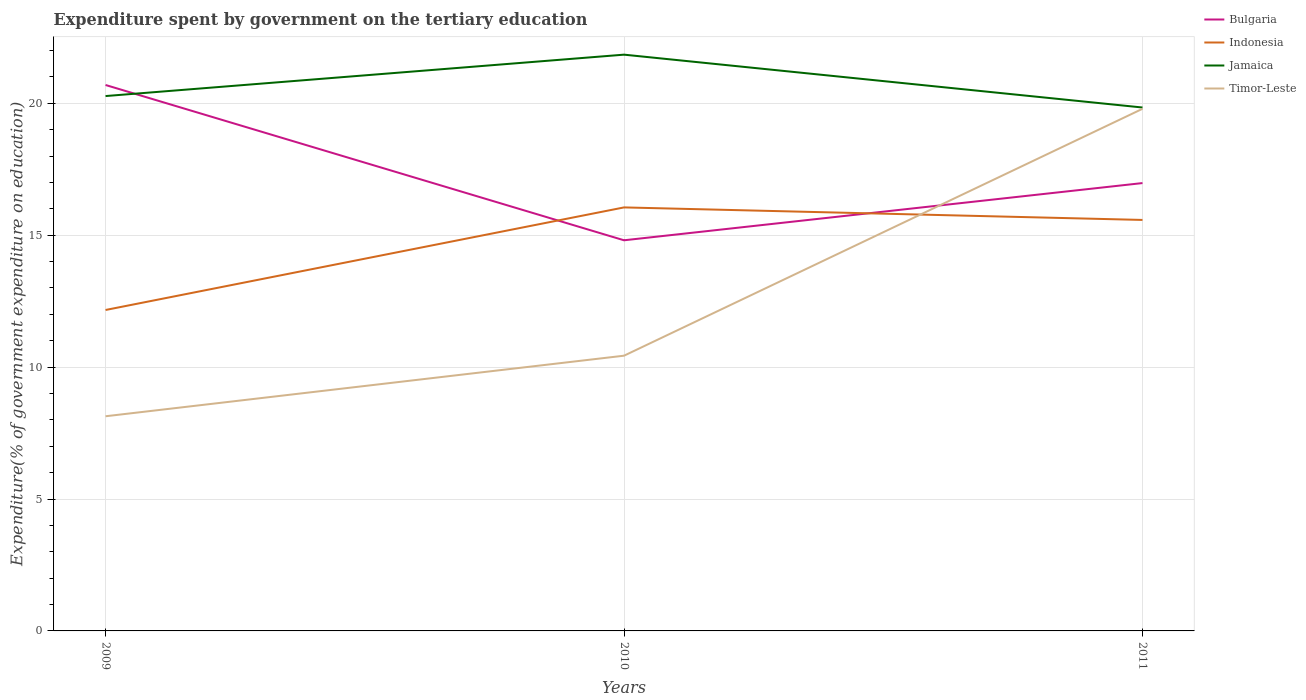How many different coloured lines are there?
Offer a very short reply. 4. Is the number of lines equal to the number of legend labels?
Give a very brief answer. Yes. Across all years, what is the maximum expenditure spent by government on the tertiary education in Bulgaria?
Your response must be concise. 14.81. What is the total expenditure spent by government on the tertiary education in Jamaica in the graph?
Provide a succinct answer. -1.57. What is the difference between the highest and the second highest expenditure spent by government on the tertiary education in Timor-Leste?
Make the answer very short. 11.65. What is the difference between the highest and the lowest expenditure spent by government on the tertiary education in Timor-Leste?
Make the answer very short. 1. Is the expenditure spent by government on the tertiary education in Indonesia strictly greater than the expenditure spent by government on the tertiary education in Jamaica over the years?
Offer a very short reply. Yes. How many lines are there?
Ensure brevity in your answer.  4. What is the difference between two consecutive major ticks on the Y-axis?
Offer a very short reply. 5. Are the values on the major ticks of Y-axis written in scientific E-notation?
Ensure brevity in your answer.  No. Does the graph contain any zero values?
Provide a succinct answer. No. Does the graph contain grids?
Your answer should be very brief. Yes. What is the title of the graph?
Ensure brevity in your answer.  Expenditure spent by government on the tertiary education. Does "Kyrgyz Republic" appear as one of the legend labels in the graph?
Your answer should be compact. No. What is the label or title of the X-axis?
Provide a short and direct response. Years. What is the label or title of the Y-axis?
Provide a short and direct response. Expenditure(% of government expenditure on education). What is the Expenditure(% of government expenditure on education) in Bulgaria in 2009?
Provide a succinct answer. 20.69. What is the Expenditure(% of government expenditure on education) of Indonesia in 2009?
Keep it short and to the point. 12.17. What is the Expenditure(% of government expenditure on education) of Jamaica in 2009?
Make the answer very short. 20.27. What is the Expenditure(% of government expenditure on education) of Timor-Leste in 2009?
Provide a short and direct response. 8.14. What is the Expenditure(% of government expenditure on education) of Bulgaria in 2010?
Offer a terse response. 14.81. What is the Expenditure(% of government expenditure on education) in Indonesia in 2010?
Provide a succinct answer. 16.05. What is the Expenditure(% of government expenditure on education) in Jamaica in 2010?
Offer a very short reply. 21.84. What is the Expenditure(% of government expenditure on education) in Timor-Leste in 2010?
Offer a terse response. 10.43. What is the Expenditure(% of government expenditure on education) of Bulgaria in 2011?
Your answer should be very brief. 16.98. What is the Expenditure(% of government expenditure on education) of Indonesia in 2011?
Provide a short and direct response. 15.58. What is the Expenditure(% of government expenditure on education) of Jamaica in 2011?
Your response must be concise. 19.84. What is the Expenditure(% of government expenditure on education) of Timor-Leste in 2011?
Give a very brief answer. 19.79. Across all years, what is the maximum Expenditure(% of government expenditure on education) of Bulgaria?
Ensure brevity in your answer.  20.69. Across all years, what is the maximum Expenditure(% of government expenditure on education) of Indonesia?
Ensure brevity in your answer.  16.05. Across all years, what is the maximum Expenditure(% of government expenditure on education) of Jamaica?
Ensure brevity in your answer.  21.84. Across all years, what is the maximum Expenditure(% of government expenditure on education) of Timor-Leste?
Provide a succinct answer. 19.79. Across all years, what is the minimum Expenditure(% of government expenditure on education) of Bulgaria?
Give a very brief answer. 14.81. Across all years, what is the minimum Expenditure(% of government expenditure on education) in Indonesia?
Make the answer very short. 12.17. Across all years, what is the minimum Expenditure(% of government expenditure on education) in Jamaica?
Your answer should be compact. 19.84. Across all years, what is the minimum Expenditure(% of government expenditure on education) in Timor-Leste?
Give a very brief answer. 8.14. What is the total Expenditure(% of government expenditure on education) of Bulgaria in the graph?
Provide a short and direct response. 52.48. What is the total Expenditure(% of government expenditure on education) in Indonesia in the graph?
Provide a short and direct response. 43.8. What is the total Expenditure(% of government expenditure on education) in Jamaica in the graph?
Your answer should be compact. 61.96. What is the total Expenditure(% of government expenditure on education) of Timor-Leste in the graph?
Your response must be concise. 38.36. What is the difference between the Expenditure(% of government expenditure on education) in Bulgaria in 2009 and that in 2010?
Provide a succinct answer. 5.89. What is the difference between the Expenditure(% of government expenditure on education) in Indonesia in 2009 and that in 2010?
Your response must be concise. -3.89. What is the difference between the Expenditure(% of government expenditure on education) of Jamaica in 2009 and that in 2010?
Your answer should be very brief. -1.57. What is the difference between the Expenditure(% of government expenditure on education) of Timor-Leste in 2009 and that in 2010?
Give a very brief answer. -2.3. What is the difference between the Expenditure(% of government expenditure on education) in Bulgaria in 2009 and that in 2011?
Keep it short and to the point. 3.72. What is the difference between the Expenditure(% of government expenditure on education) in Indonesia in 2009 and that in 2011?
Offer a terse response. -3.41. What is the difference between the Expenditure(% of government expenditure on education) in Jamaica in 2009 and that in 2011?
Give a very brief answer. 0.43. What is the difference between the Expenditure(% of government expenditure on education) of Timor-Leste in 2009 and that in 2011?
Ensure brevity in your answer.  -11.65. What is the difference between the Expenditure(% of government expenditure on education) in Bulgaria in 2010 and that in 2011?
Offer a terse response. -2.17. What is the difference between the Expenditure(% of government expenditure on education) in Indonesia in 2010 and that in 2011?
Make the answer very short. 0.47. What is the difference between the Expenditure(% of government expenditure on education) of Jamaica in 2010 and that in 2011?
Your answer should be compact. 2. What is the difference between the Expenditure(% of government expenditure on education) of Timor-Leste in 2010 and that in 2011?
Make the answer very short. -9.36. What is the difference between the Expenditure(% of government expenditure on education) of Bulgaria in 2009 and the Expenditure(% of government expenditure on education) of Indonesia in 2010?
Keep it short and to the point. 4.64. What is the difference between the Expenditure(% of government expenditure on education) in Bulgaria in 2009 and the Expenditure(% of government expenditure on education) in Jamaica in 2010?
Your answer should be compact. -1.15. What is the difference between the Expenditure(% of government expenditure on education) of Bulgaria in 2009 and the Expenditure(% of government expenditure on education) of Timor-Leste in 2010?
Give a very brief answer. 10.26. What is the difference between the Expenditure(% of government expenditure on education) in Indonesia in 2009 and the Expenditure(% of government expenditure on education) in Jamaica in 2010?
Offer a very short reply. -9.68. What is the difference between the Expenditure(% of government expenditure on education) in Indonesia in 2009 and the Expenditure(% of government expenditure on education) in Timor-Leste in 2010?
Ensure brevity in your answer.  1.73. What is the difference between the Expenditure(% of government expenditure on education) in Jamaica in 2009 and the Expenditure(% of government expenditure on education) in Timor-Leste in 2010?
Provide a succinct answer. 9.84. What is the difference between the Expenditure(% of government expenditure on education) of Bulgaria in 2009 and the Expenditure(% of government expenditure on education) of Indonesia in 2011?
Offer a terse response. 5.12. What is the difference between the Expenditure(% of government expenditure on education) in Bulgaria in 2009 and the Expenditure(% of government expenditure on education) in Jamaica in 2011?
Give a very brief answer. 0.85. What is the difference between the Expenditure(% of government expenditure on education) of Bulgaria in 2009 and the Expenditure(% of government expenditure on education) of Timor-Leste in 2011?
Ensure brevity in your answer.  0.9. What is the difference between the Expenditure(% of government expenditure on education) in Indonesia in 2009 and the Expenditure(% of government expenditure on education) in Jamaica in 2011?
Your answer should be compact. -7.67. What is the difference between the Expenditure(% of government expenditure on education) in Indonesia in 2009 and the Expenditure(% of government expenditure on education) in Timor-Leste in 2011?
Offer a very short reply. -7.63. What is the difference between the Expenditure(% of government expenditure on education) of Jamaica in 2009 and the Expenditure(% of government expenditure on education) of Timor-Leste in 2011?
Give a very brief answer. 0.48. What is the difference between the Expenditure(% of government expenditure on education) in Bulgaria in 2010 and the Expenditure(% of government expenditure on education) in Indonesia in 2011?
Make the answer very short. -0.77. What is the difference between the Expenditure(% of government expenditure on education) in Bulgaria in 2010 and the Expenditure(% of government expenditure on education) in Jamaica in 2011?
Provide a short and direct response. -5.03. What is the difference between the Expenditure(% of government expenditure on education) in Bulgaria in 2010 and the Expenditure(% of government expenditure on education) in Timor-Leste in 2011?
Offer a terse response. -4.98. What is the difference between the Expenditure(% of government expenditure on education) of Indonesia in 2010 and the Expenditure(% of government expenditure on education) of Jamaica in 2011?
Offer a terse response. -3.79. What is the difference between the Expenditure(% of government expenditure on education) in Indonesia in 2010 and the Expenditure(% of government expenditure on education) in Timor-Leste in 2011?
Make the answer very short. -3.74. What is the difference between the Expenditure(% of government expenditure on education) in Jamaica in 2010 and the Expenditure(% of government expenditure on education) in Timor-Leste in 2011?
Your answer should be compact. 2.05. What is the average Expenditure(% of government expenditure on education) in Bulgaria per year?
Give a very brief answer. 17.49. What is the average Expenditure(% of government expenditure on education) of Indonesia per year?
Provide a short and direct response. 14.6. What is the average Expenditure(% of government expenditure on education) in Jamaica per year?
Your answer should be very brief. 20.65. What is the average Expenditure(% of government expenditure on education) of Timor-Leste per year?
Provide a short and direct response. 12.79. In the year 2009, what is the difference between the Expenditure(% of government expenditure on education) in Bulgaria and Expenditure(% of government expenditure on education) in Indonesia?
Provide a succinct answer. 8.53. In the year 2009, what is the difference between the Expenditure(% of government expenditure on education) of Bulgaria and Expenditure(% of government expenditure on education) of Jamaica?
Your answer should be compact. 0.42. In the year 2009, what is the difference between the Expenditure(% of government expenditure on education) of Bulgaria and Expenditure(% of government expenditure on education) of Timor-Leste?
Offer a terse response. 12.56. In the year 2009, what is the difference between the Expenditure(% of government expenditure on education) in Indonesia and Expenditure(% of government expenditure on education) in Jamaica?
Your answer should be very brief. -8.11. In the year 2009, what is the difference between the Expenditure(% of government expenditure on education) in Indonesia and Expenditure(% of government expenditure on education) in Timor-Leste?
Provide a succinct answer. 4.03. In the year 2009, what is the difference between the Expenditure(% of government expenditure on education) of Jamaica and Expenditure(% of government expenditure on education) of Timor-Leste?
Your answer should be compact. 12.14. In the year 2010, what is the difference between the Expenditure(% of government expenditure on education) of Bulgaria and Expenditure(% of government expenditure on education) of Indonesia?
Offer a very short reply. -1.25. In the year 2010, what is the difference between the Expenditure(% of government expenditure on education) in Bulgaria and Expenditure(% of government expenditure on education) in Jamaica?
Provide a short and direct response. -7.04. In the year 2010, what is the difference between the Expenditure(% of government expenditure on education) in Bulgaria and Expenditure(% of government expenditure on education) in Timor-Leste?
Provide a short and direct response. 4.37. In the year 2010, what is the difference between the Expenditure(% of government expenditure on education) in Indonesia and Expenditure(% of government expenditure on education) in Jamaica?
Make the answer very short. -5.79. In the year 2010, what is the difference between the Expenditure(% of government expenditure on education) of Indonesia and Expenditure(% of government expenditure on education) of Timor-Leste?
Offer a very short reply. 5.62. In the year 2010, what is the difference between the Expenditure(% of government expenditure on education) of Jamaica and Expenditure(% of government expenditure on education) of Timor-Leste?
Keep it short and to the point. 11.41. In the year 2011, what is the difference between the Expenditure(% of government expenditure on education) of Bulgaria and Expenditure(% of government expenditure on education) of Indonesia?
Your answer should be compact. 1.4. In the year 2011, what is the difference between the Expenditure(% of government expenditure on education) in Bulgaria and Expenditure(% of government expenditure on education) in Jamaica?
Your answer should be compact. -2.86. In the year 2011, what is the difference between the Expenditure(% of government expenditure on education) in Bulgaria and Expenditure(% of government expenditure on education) in Timor-Leste?
Provide a succinct answer. -2.81. In the year 2011, what is the difference between the Expenditure(% of government expenditure on education) in Indonesia and Expenditure(% of government expenditure on education) in Jamaica?
Offer a very short reply. -4.26. In the year 2011, what is the difference between the Expenditure(% of government expenditure on education) of Indonesia and Expenditure(% of government expenditure on education) of Timor-Leste?
Offer a very short reply. -4.21. In the year 2011, what is the difference between the Expenditure(% of government expenditure on education) in Jamaica and Expenditure(% of government expenditure on education) in Timor-Leste?
Provide a short and direct response. 0.05. What is the ratio of the Expenditure(% of government expenditure on education) in Bulgaria in 2009 to that in 2010?
Your answer should be very brief. 1.4. What is the ratio of the Expenditure(% of government expenditure on education) in Indonesia in 2009 to that in 2010?
Your answer should be very brief. 0.76. What is the ratio of the Expenditure(% of government expenditure on education) in Jamaica in 2009 to that in 2010?
Keep it short and to the point. 0.93. What is the ratio of the Expenditure(% of government expenditure on education) in Timor-Leste in 2009 to that in 2010?
Your response must be concise. 0.78. What is the ratio of the Expenditure(% of government expenditure on education) in Bulgaria in 2009 to that in 2011?
Offer a terse response. 1.22. What is the ratio of the Expenditure(% of government expenditure on education) of Indonesia in 2009 to that in 2011?
Provide a short and direct response. 0.78. What is the ratio of the Expenditure(% of government expenditure on education) in Jamaica in 2009 to that in 2011?
Your answer should be compact. 1.02. What is the ratio of the Expenditure(% of government expenditure on education) in Timor-Leste in 2009 to that in 2011?
Ensure brevity in your answer.  0.41. What is the ratio of the Expenditure(% of government expenditure on education) in Bulgaria in 2010 to that in 2011?
Ensure brevity in your answer.  0.87. What is the ratio of the Expenditure(% of government expenditure on education) of Indonesia in 2010 to that in 2011?
Make the answer very short. 1.03. What is the ratio of the Expenditure(% of government expenditure on education) in Jamaica in 2010 to that in 2011?
Keep it short and to the point. 1.1. What is the ratio of the Expenditure(% of government expenditure on education) of Timor-Leste in 2010 to that in 2011?
Offer a very short reply. 0.53. What is the difference between the highest and the second highest Expenditure(% of government expenditure on education) of Bulgaria?
Your answer should be very brief. 3.72. What is the difference between the highest and the second highest Expenditure(% of government expenditure on education) in Indonesia?
Keep it short and to the point. 0.47. What is the difference between the highest and the second highest Expenditure(% of government expenditure on education) of Jamaica?
Provide a short and direct response. 1.57. What is the difference between the highest and the second highest Expenditure(% of government expenditure on education) in Timor-Leste?
Ensure brevity in your answer.  9.36. What is the difference between the highest and the lowest Expenditure(% of government expenditure on education) in Bulgaria?
Provide a short and direct response. 5.89. What is the difference between the highest and the lowest Expenditure(% of government expenditure on education) of Indonesia?
Offer a very short reply. 3.89. What is the difference between the highest and the lowest Expenditure(% of government expenditure on education) of Jamaica?
Provide a short and direct response. 2. What is the difference between the highest and the lowest Expenditure(% of government expenditure on education) of Timor-Leste?
Your answer should be very brief. 11.65. 